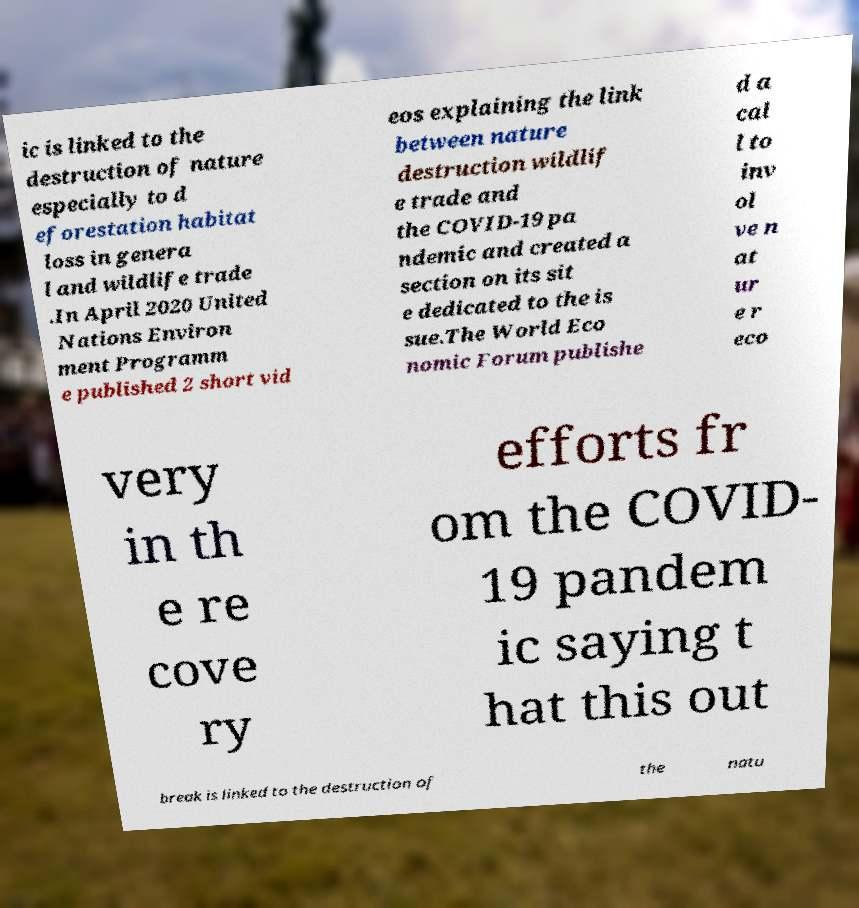What messages or text are displayed in this image? I need them in a readable, typed format. ic is linked to the destruction of nature especially to d eforestation habitat loss in genera l and wildlife trade .In April 2020 United Nations Environ ment Programm e published 2 short vid eos explaining the link between nature destruction wildlif e trade and the COVID-19 pa ndemic and created a section on its sit e dedicated to the is sue.The World Eco nomic Forum publishe d a cal l to inv ol ve n at ur e r eco very in th e re cove ry efforts fr om the COVID- 19 pandem ic saying t hat this out break is linked to the destruction of the natu 